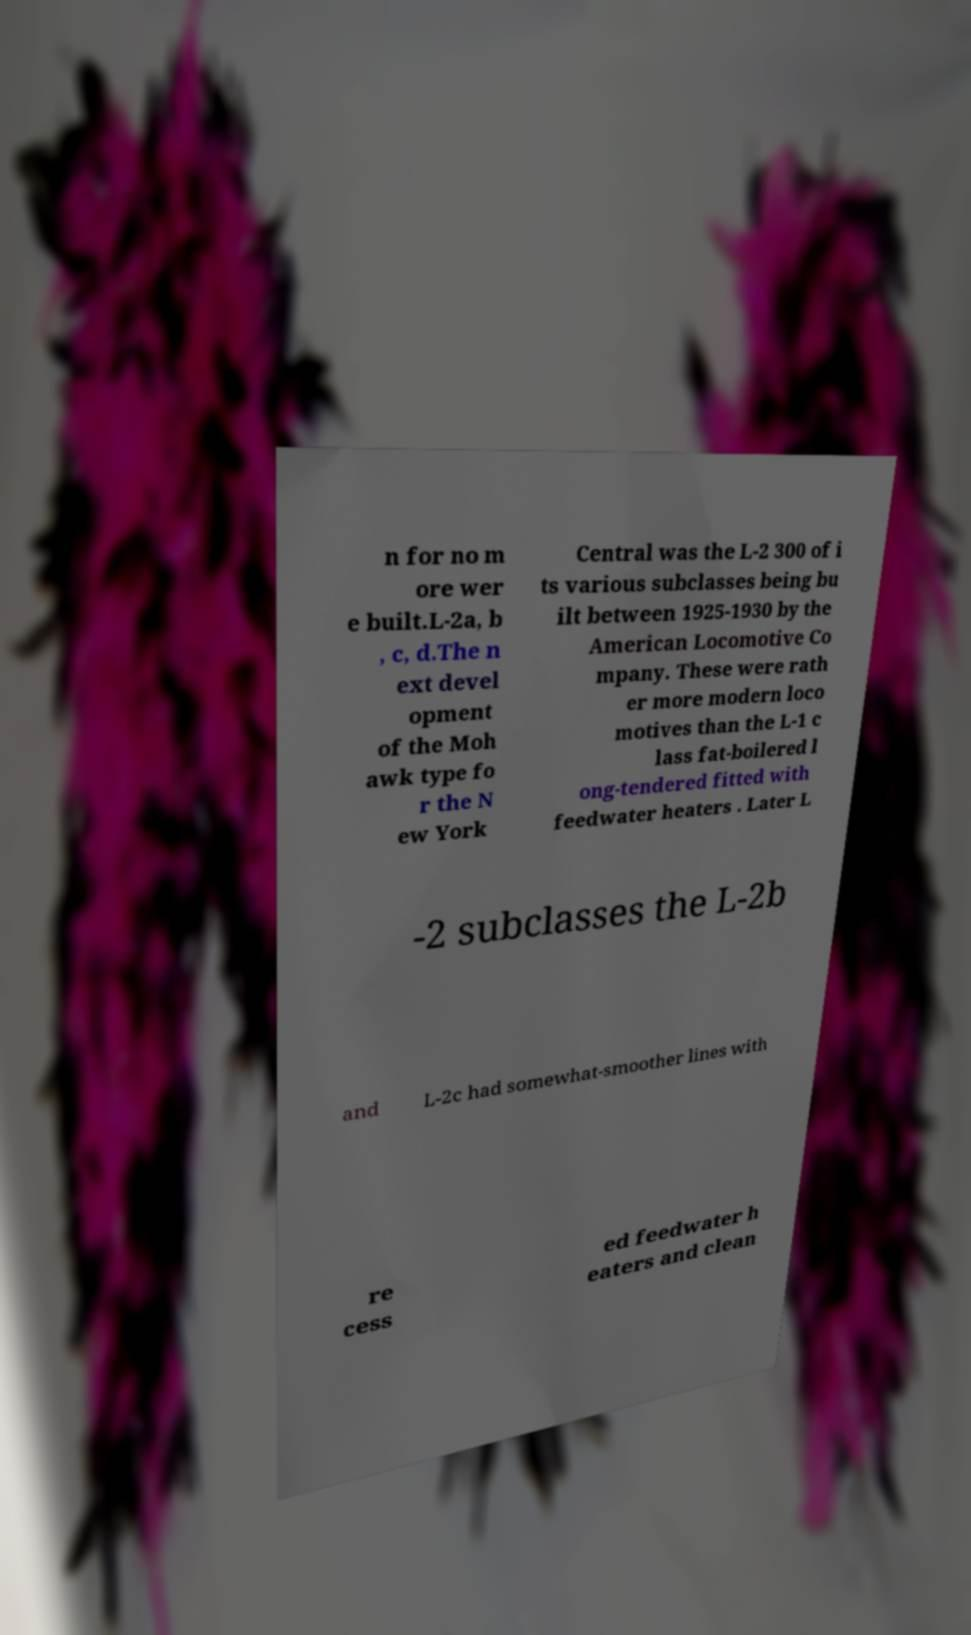For documentation purposes, I need the text within this image transcribed. Could you provide that? n for no m ore wer e built.L-2a, b , c, d.The n ext devel opment of the Moh awk type fo r the N ew York Central was the L-2 300 of i ts various subclasses being bu ilt between 1925-1930 by the American Locomotive Co mpany. These were rath er more modern loco motives than the L-1 c lass fat-boilered l ong-tendered fitted with feedwater heaters . Later L -2 subclasses the L-2b and L-2c had somewhat-smoother lines with re cess ed feedwater h eaters and clean 